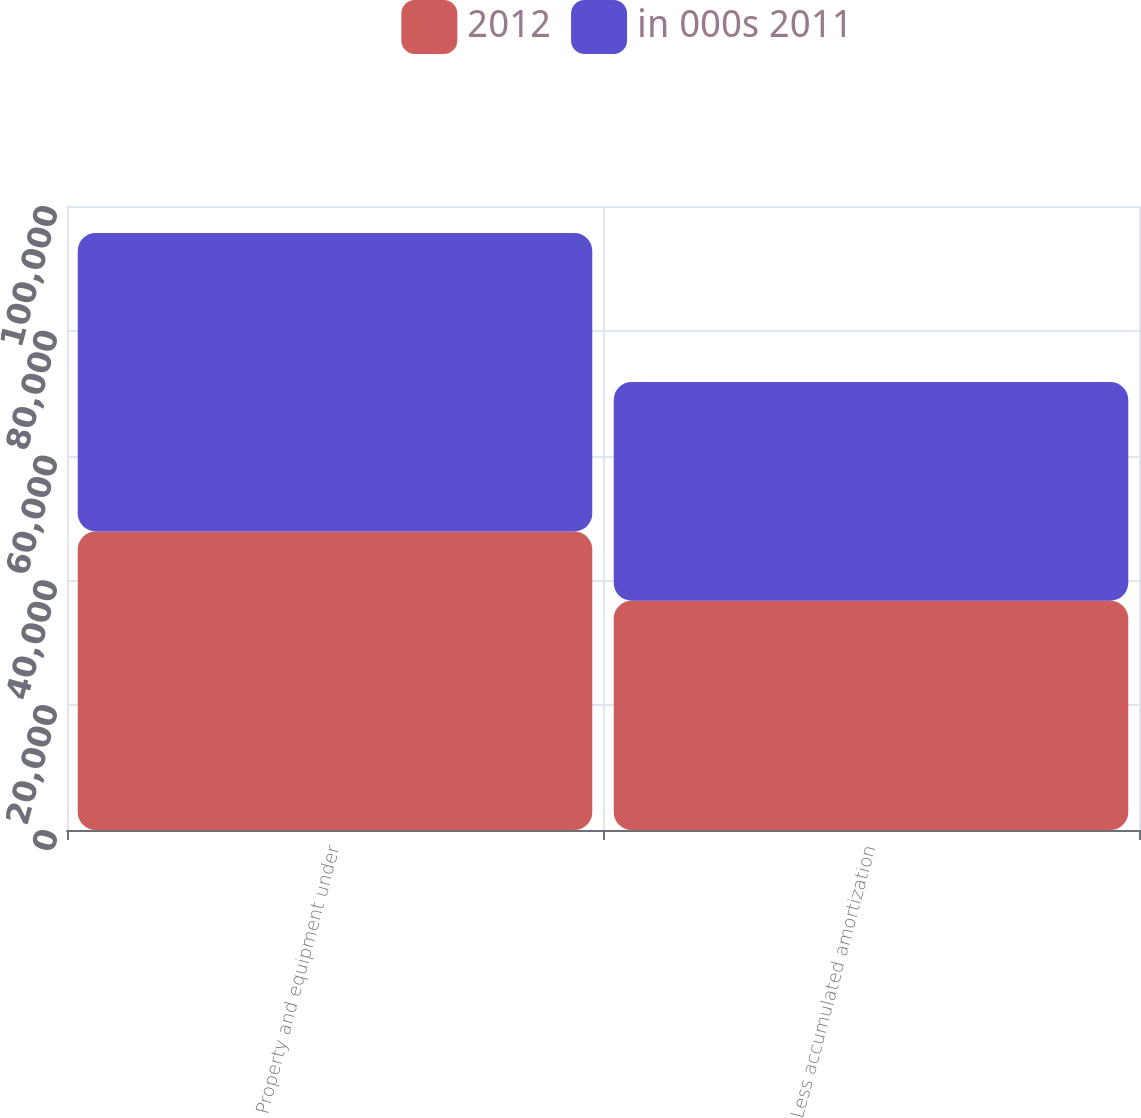<chart> <loc_0><loc_0><loc_500><loc_500><stacked_bar_chart><ecel><fcel>Property and equipment under<fcel>Less accumulated amortization<nl><fcel>2012<fcel>47842<fcel>36740<nl><fcel>in 000s 2011<fcel>47842<fcel>35056<nl></chart> 